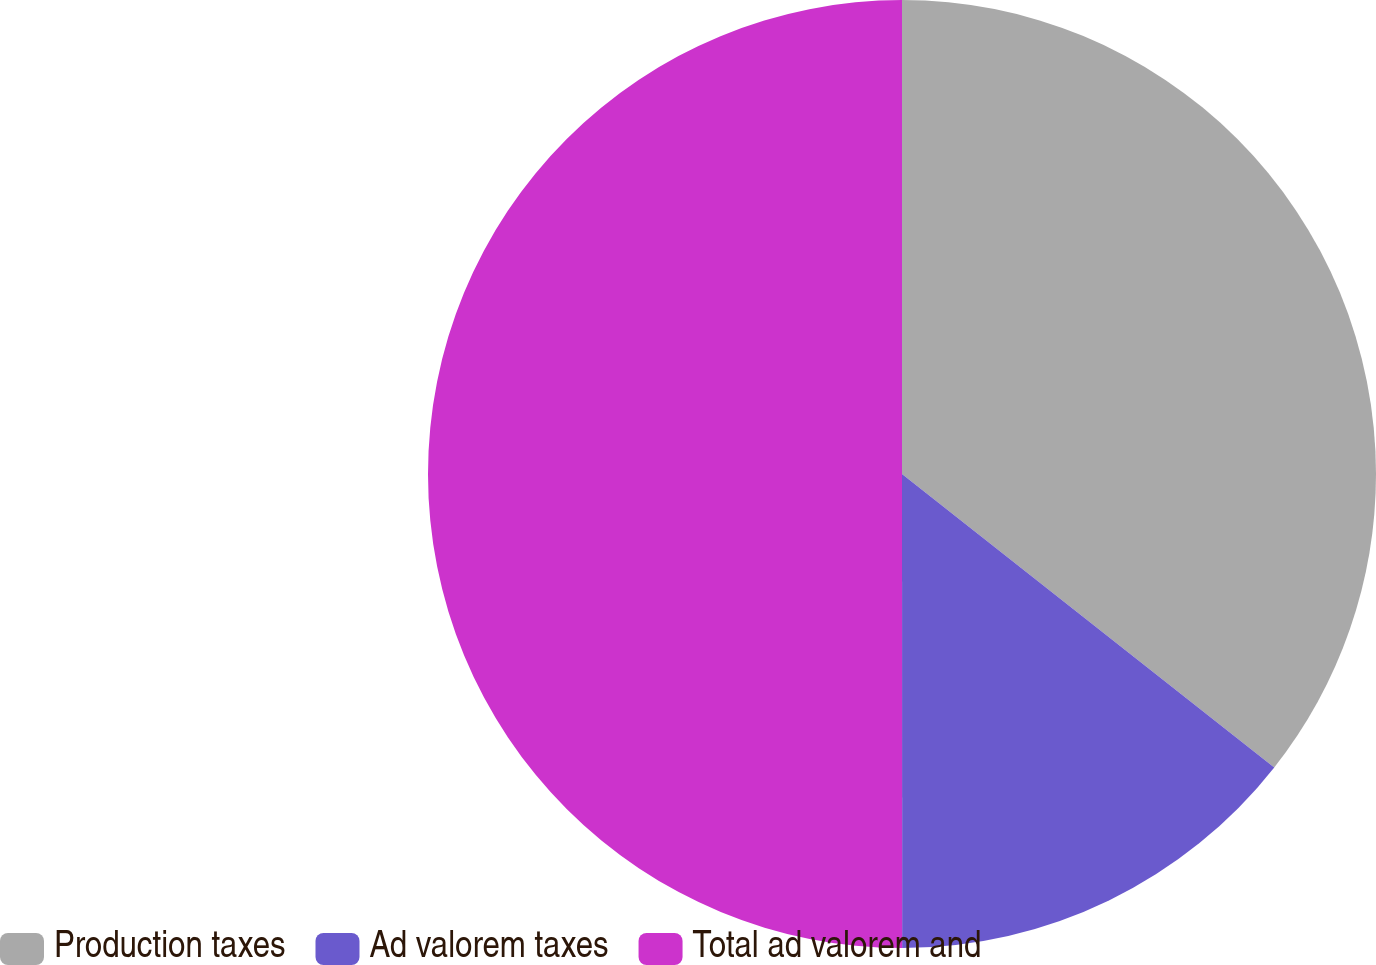Convert chart. <chart><loc_0><loc_0><loc_500><loc_500><pie_chart><fcel>Production taxes<fcel>Ad valorem taxes<fcel>Total ad valorem and<nl><fcel>35.62%<fcel>14.37%<fcel>50.0%<nl></chart> 